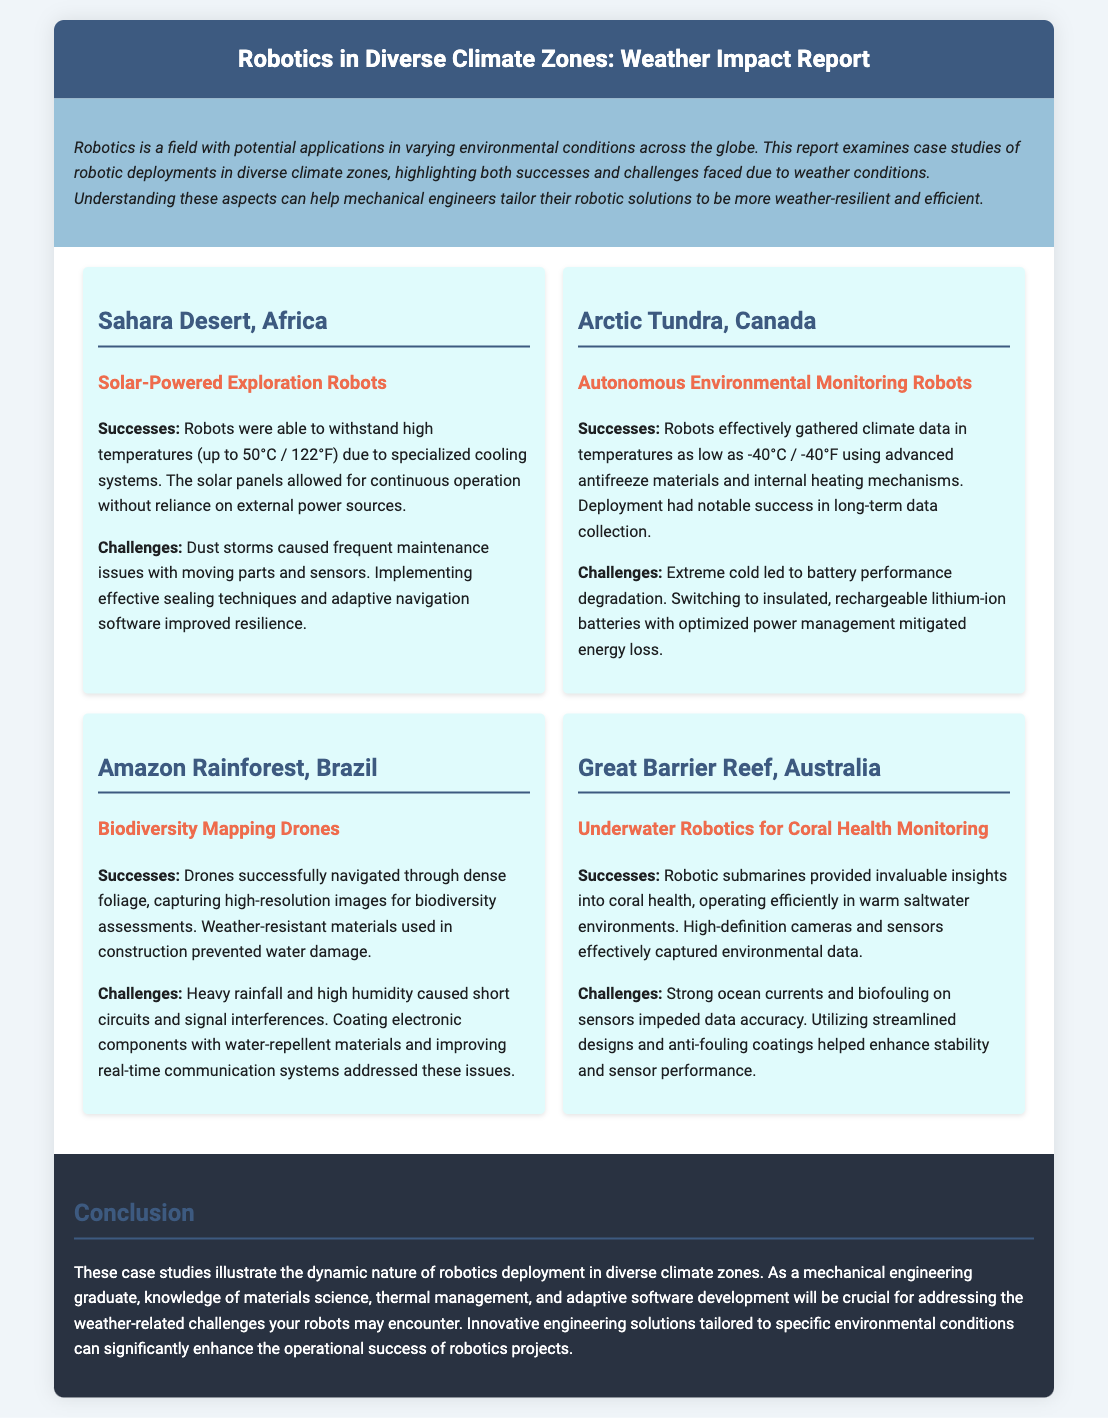What is the temperature range in the Sahara Desert case study? The document specifies that robots withstood high temperatures up to 50°C in the Sahara Desert case study.
Answer: 50°C What challenges were faced by robots in the Arctic Tundra? The challenges mentioned include battery performance degradation due to extreme cold.
Answer: Battery performance degradation What type of robots were used in the Amazon Rainforest? The case study discusses the use of biodiversity mapping drones in the Amazon Rainforest.
Answer: Biodiversity mapping drones What material was used for high-temperature operation in the Sahara Desert? Specialized cooling systems were mentioned as being used for high-temperature operation in the Sahara.
Answer: Specialized cooling systems Which climate zone's robots used antifreeze materials? The Arctic Tundra case study refers to the use of antifreeze materials in autonomous environmental monitoring robots.
Answer: Arctic Tundra What was a major success of the underwater robots in the Great Barrier Reef? The document highlights that robotic submarines provided invaluable insights into coral health.
Answer: Insights into coral health What specific issue did heavy rainfall cause for drones in the Amazon? Heavy rainfall caused short circuits and signal interferences for the drones in the Amazon Rainforest.
Answer: Short circuits What innovative solution improved operations in the Great Barrier Reef? Utilizing streamlined designs and anti-fouling coatings improved operations in the Great Barrier Reef.
Answer: Streamlined designs and anti-fouling coatings What does the conclusion emphasize for mechanical engineers? The conclusion emphasizes knowledge of materials science, thermal management, and adaptive software development for engineers.
Answer: Knowledge of materials science, thermal management, and adaptive software development 